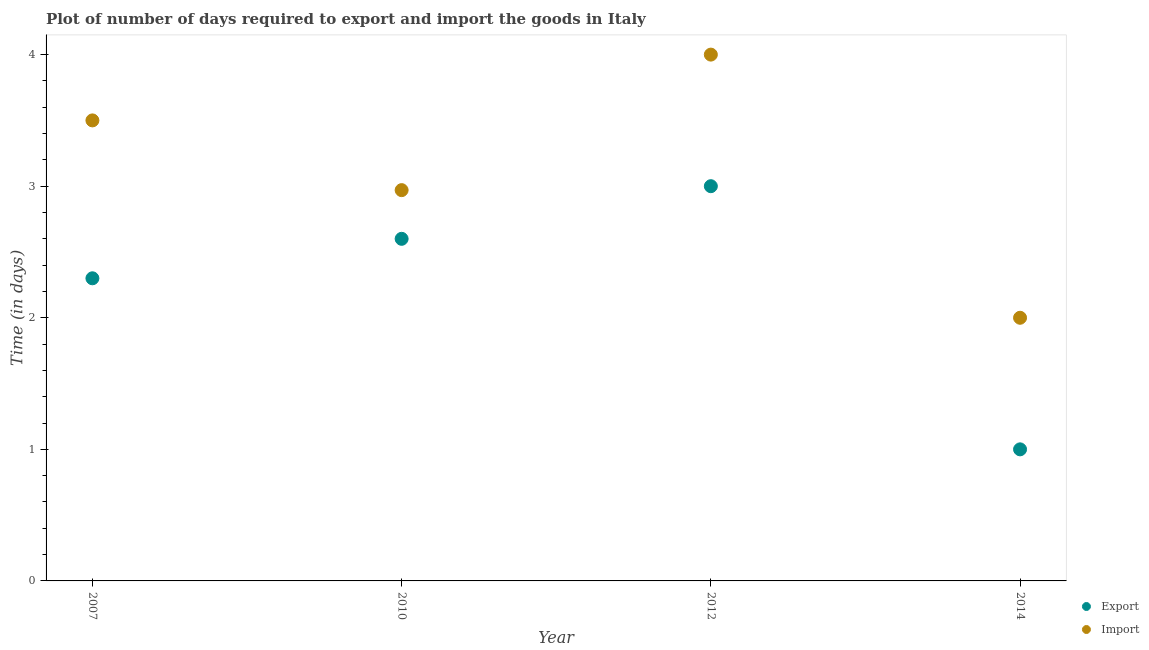Is the number of dotlines equal to the number of legend labels?
Provide a succinct answer. Yes. Across all years, what is the minimum time required to export?
Your answer should be compact. 1. In which year was the time required to import maximum?
Keep it short and to the point. 2012. In which year was the time required to export minimum?
Give a very brief answer. 2014. What is the total time required to import in the graph?
Ensure brevity in your answer.  12.47. What is the difference between the time required to import in 2007 and that in 2014?
Ensure brevity in your answer.  1.5. What is the difference between the time required to export in 2007 and the time required to import in 2014?
Make the answer very short. 0.3. What is the average time required to import per year?
Your answer should be compact. 3.12. In the year 2007, what is the difference between the time required to import and time required to export?
Offer a terse response. 1.2. In how many years, is the time required to export greater than 1.6 days?
Offer a terse response. 3. What is the ratio of the time required to import in 2007 to that in 2012?
Ensure brevity in your answer.  0.88. Is the difference between the time required to export in 2010 and 2014 greater than the difference between the time required to import in 2010 and 2014?
Offer a very short reply. Yes. What is the difference between the highest and the second highest time required to export?
Offer a very short reply. 0.4. Is the sum of the time required to import in 2007 and 2014 greater than the maximum time required to export across all years?
Keep it short and to the point. Yes. Does the time required to import monotonically increase over the years?
Your answer should be compact. No. Is the time required to import strictly greater than the time required to export over the years?
Provide a short and direct response. Yes. How many years are there in the graph?
Offer a terse response. 4. What is the difference between two consecutive major ticks on the Y-axis?
Make the answer very short. 1. Are the values on the major ticks of Y-axis written in scientific E-notation?
Your response must be concise. No. Does the graph contain any zero values?
Offer a very short reply. No. How are the legend labels stacked?
Your answer should be compact. Vertical. What is the title of the graph?
Provide a succinct answer. Plot of number of days required to export and import the goods in Italy. What is the label or title of the X-axis?
Ensure brevity in your answer.  Year. What is the label or title of the Y-axis?
Provide a succinct answer. Time (in days). What is the Time (in days) in Export in 2010?
Provide a short and direct response. 2.6. What is the Time (in days) in Import in 2010?
Provide a short and direct response. 2.97. Across all years, what is the maximum Time (in days) of Export?
Your answer should be very brief. 3. Across all years, what is the maximum Time (in days) in Import?
Offer a terse response. 4. Across all years, what is the minimum Time (in days) of Import?
Provide a succinct answer. 2. What is the total Time (in days) in Export in the graph?
Ensure brevity in your answer.  8.9. What is the total Time (in days) of Import in the graph?
Offer a very short reply. 12.47. What is the difference between the Time (in days) in Import in 2007 and that in 2010?
Provide a succinct answer. 0.53. What is the difference between the Time (in days) in Export in 2007 and that in 2014?
Provide a succinct answer. 1.3. What is the difference between the Time (in days) in Export in 2010 and that in 2012?
Your answer should be compact. -0.4. What is the difference between the Time (in days) in Import in 2010 and that in 2012?
Offer a very short reply. -1.03. What is the difference between the Time (in days) in Export in 2010 and that in 2014?
Give a very brief answer. 1.6. What is the difference between the Time (in days) in Import in 2010 and that in 2014?
Give a very brief answer. 0.97. What is the difference between the Time (in days) of Export in 2012 and that in 2014?
Ensure brevity in your answer.  2. What is the difference between the Time (in days) in Import in 2012 and that in 2014?
Your answer should be compact. 2. What is the difference between the Time (in days) of Export in 2007 and the Time (in days) of Import in 2010?
Offer a very short reply. -0.67. What is the difference between the Time (in days) in Export in 2007 and the Time (in days) in Import in 2014?
Provide a short and direct response. 0.3. What is the difference between the Time (in days) of Export in 2010 and the Time (in days) of Import in 2014?
Offer a very short reply. 0.6. What is the difference between the Time (in days) of Export in 2012 and the Time (in days) of Import in 2014?
Give a very brief answer. 1. What is the average Time (in days) of Export per year?
Provide a short and direct response. 2.23. What is the average Time (in days) in Import per year?
Your answer should be very brief. 3.12. In the year 2010, what is the difference between the Time (in days) in Export and Time (in days) in Import?
Your answer should be very brief. -0.37. What is the ratio of the Time (in days) in Export in 2007 to that in 2010?
Keep it short and to the point. 0.88. What is the ratio of the Time (in days) of Import in 2007 to that in 2010?
Keep it short and to the point. 1.18. What is the ratio of the Time (in days) in Export in 2007 to that in 2012?
Your answer should be very brief. 0.77. What is the ratio of the Time (in days) in Import in 2007 to that in 2012?
Make the answer very short. 0.88. What is the ratio of the Time (in days) of Export in 2007 to that in 2014?
Offer a very short reply. 2.3. What is the ratio of the Time (in days) in Export in 2010 to that in 2012?
Offer a terse response. 0.87. What is the ratio of the Time (in days) of Import in 2010 to that in 2012?
Offer a terse response. 0.74. What is the ratio of the Time (in days) of Import in 2010 to that in 2014?
Provide a short and direct response. 1.49. What is the ratio of the Time (in days) in Export in 2012 to that in 2014?
Your response must be concise. 3. What is the difference between the highest and the lowest Time (in days) of Import?
Offer a very short reply. 2. 